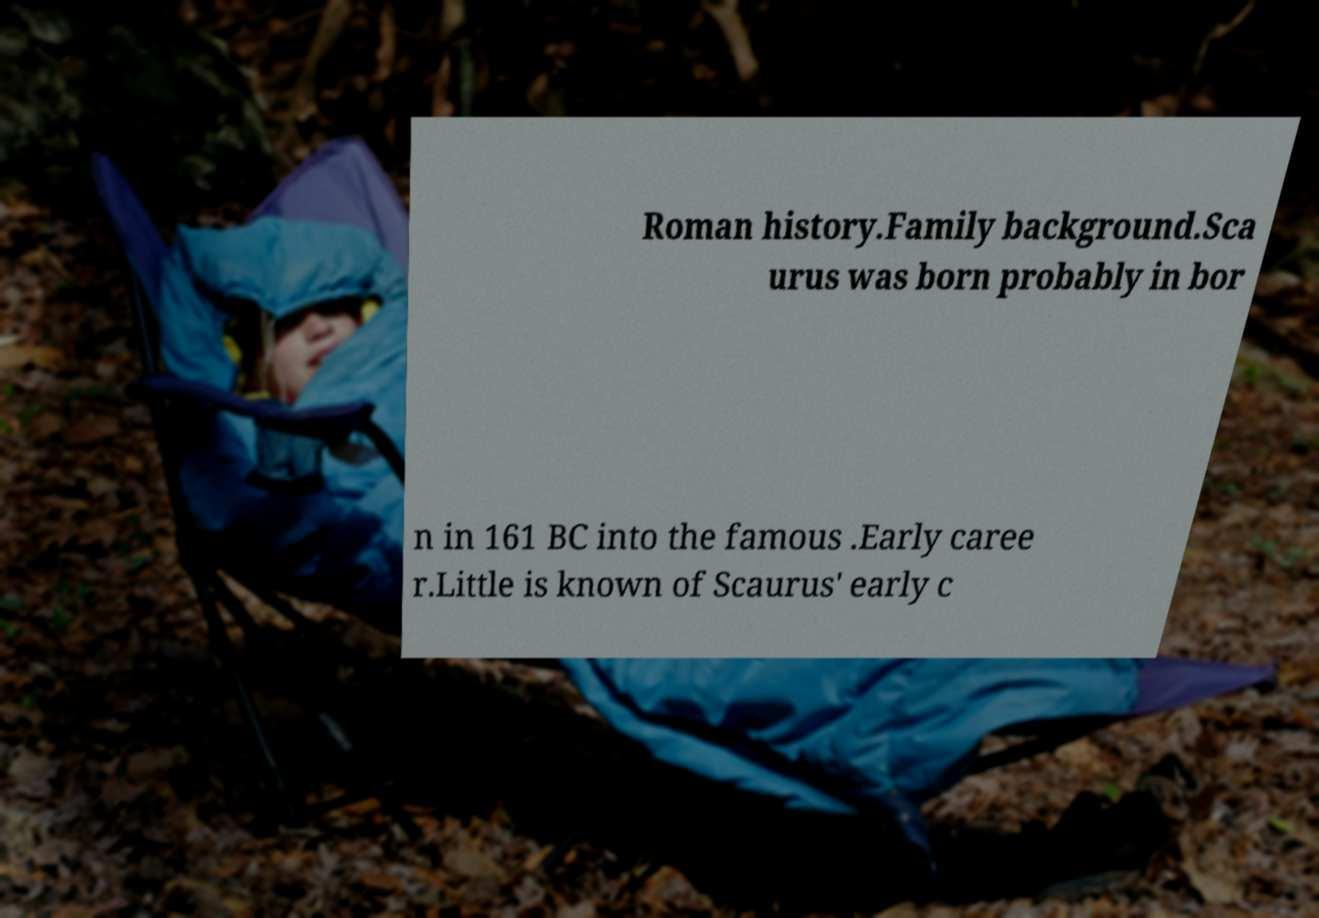For documentation purposes, I need the text within this image transcribed. Could you provide that? Roman history.Family background.Sca urus was born probably in bor n in 161 BC into the famous .Early caree r.Little is known of Scaurus' early c 